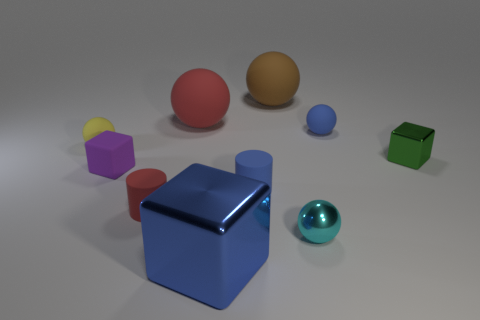Subtract all yellow balls. How many balls are left? 4 Subtract all blue rubber balls. How many balls are left? 4 Subtract all blue spheres. Subtract all gray cylinders. How many spheres are left? 4 Subtract all cubes. How many objects are left? 7 Add 8 red matte spheres. How many red matte spheres exist? 9 Subtract 0 green cylinders. How many objects are left? 10 Subtract all blue cubes. Subtract all tiny yellow matte things. How many objects are left? 8 Add 5 small cylinders. How many small cylinders are left? 7 